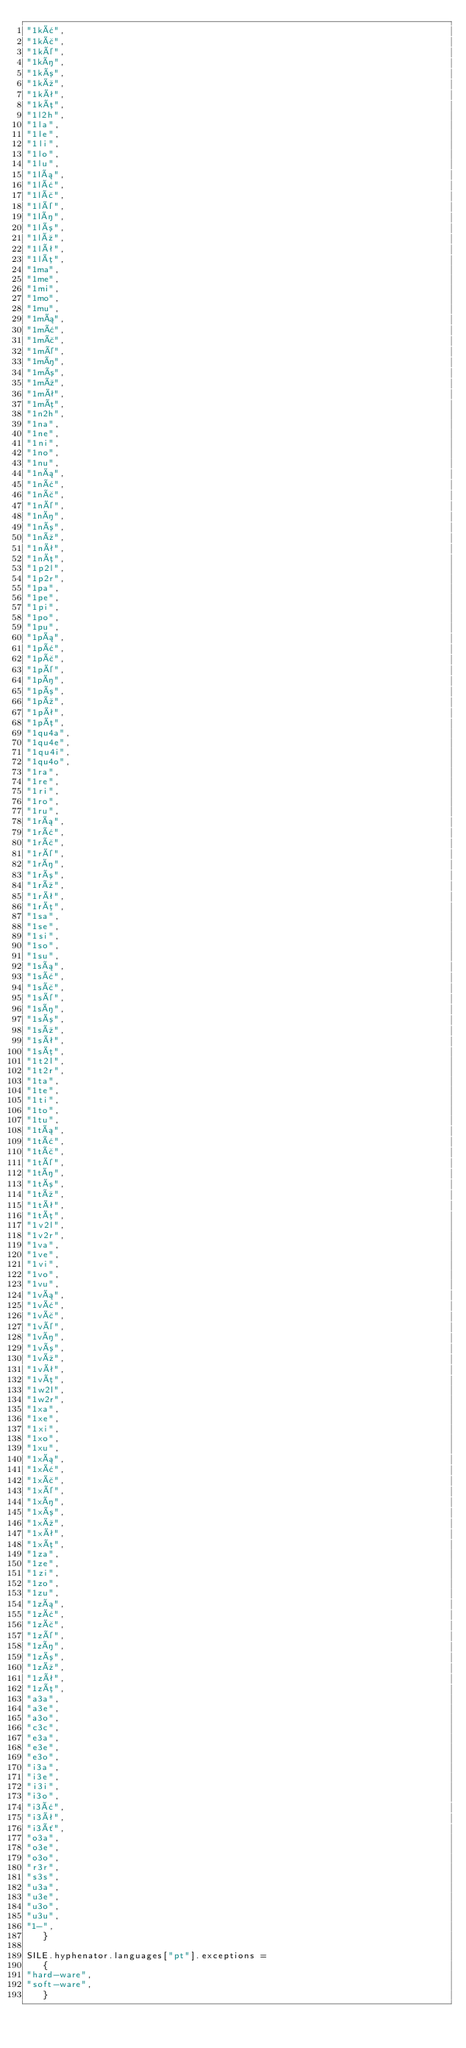<code> <loc_0><loc_0><loc_500><loc_500><_Lua_>"1kâ",
"1kã",
"1ké",
"1kí",
"1kó",
"1kú",
"1kê",
"1kõ",
"1l2h",
"1la",
"1le",
"1li",
"1lo",
"1lu",
"1lá",
"1lâ",
"1lã",
"1lé",
"1lí",
"1ló",
"1lú",
"1lê",
"1lõ",
"1ma",
"1me",
"1mi",
"1mo",
"1mu",
"1má",
"1mâ",
"1mã",
"1mé",
"1mí",
"1mó",
"1mú",
"1mê",
"1mõ",
"1n2h",
"1na",
"1ne",
"1ni",
"1no",
"1nu",
"1ná",
"1nâ",
"1nã",
"1né",
"1ní",
"1nó",
"1nú",
"1nê",
"1nõ",
"1p2l",
"1p2r",
"1pa",
"1pe",
"1pi",
"1po",
"1pu",
"1pá",
"1pâ",
"1pã",
"1pé",
"1pí",
"1pó",
"1pú",
"1pê",
"1põ",
"1qu4a",
"1qu4e",
"1qu4i",
"1qu4o",
"1ra",
"1re",
"1ri",
"1ro",
"1ru",
"1rá",
"1râ",
"1rã",
"1ré",
"1rí",
"1ró",
"1rú",
"1rê",
"1rõ",
"1sa",
"1se",
"1si",
"1so",
"1su",
"1sá",
"1sâ",
"1sã",
"1sé",
"1sí",
"1só",
"1sú",
"1sê",
"1sõ",
"1t2l",
"1t2r",
"1ta",
"1te",
"1ti",
"1to",
"1tu",
"1tá",
"1tâ",
"1tã",
"1té",
"1tí",
"1tó",
"1tú",
"1tê",
"1tõ",
"1v2l",
"1v2r",
"1va",
"1ve",
"1vi",
"1vo",
"1vu",
"1vá",
"1vâ",
"1vã",
"1vé",
"1ví",
"1vó",
"1vú",
"1vê",
"1võ",
"1w2l",
"1w2r",
"1xa",
"1xe",
"1xi",
"1xo",
"1xu",
"1xá",
"1xâ",
"1xã",
"1xé",
"1xí",
"1xó",
"1xú",
"1xê",
"1xõ",
"1za",
"1ze",
"1zi",
"1zo",
"1zu",
"1zá",
"1zâ",
"1zã",
"1zé",
"1zí",
"1zó",
"1zú",
"1zê",
"1zõ",
"a3a",
"a3e",
"a3o",
"c3c",
"e3a",
"e3e",
"e3o",
"i3a",
"i3e",
"i3i",
"i3o",
"i3â",
"i3ê",
"i3ô",
"o3a",
"o3e",
"o3o",
"r3r",
"s3s",
"u3a",
"u3e",
"u3o",
"u3u",
"1-",
   }

SILE.hyphenator.languages["pt"].exceptions =
   {
"hard-ware",
"soft-ware",
   }
</code> 